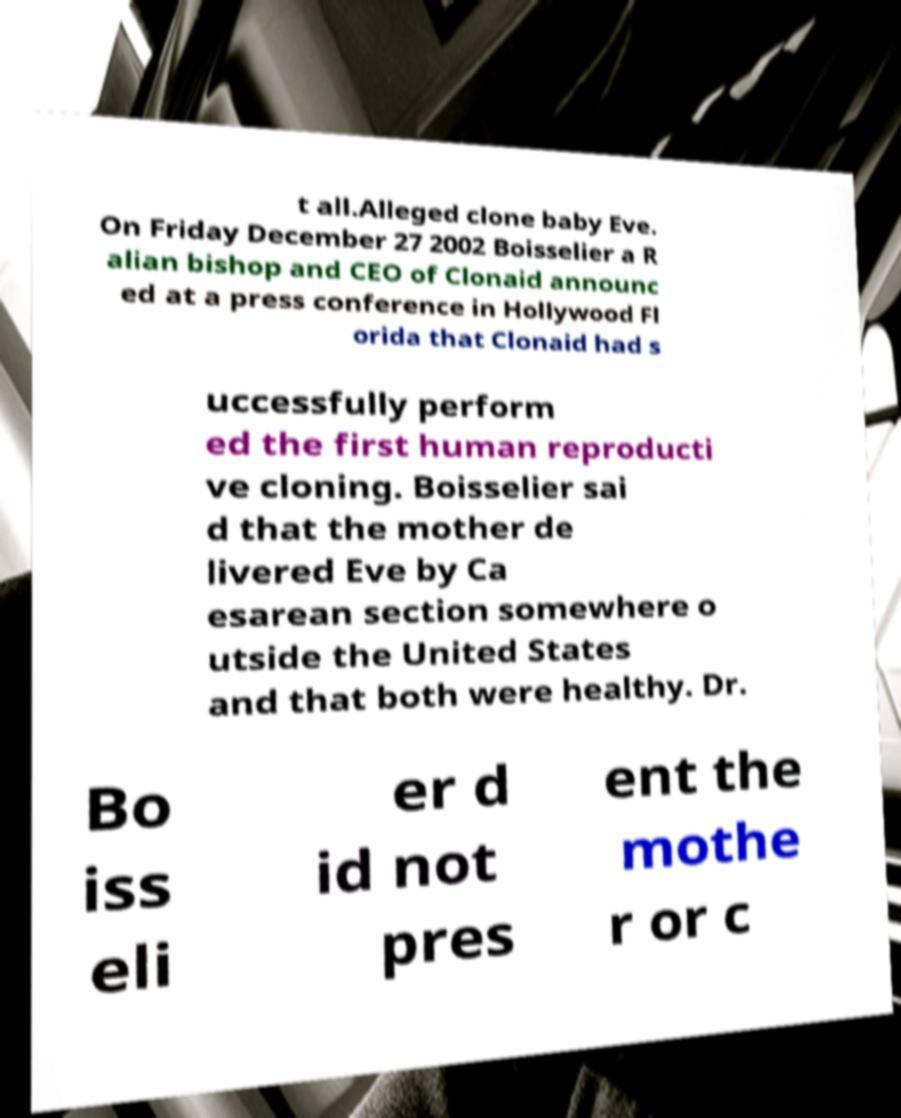Please identify and transcribe the text found in this image. t all.Alleged clone baby Eve. On Friday December 27 2002 Boisselier a R alian bishop and CEO of Clonaid announc ed at a press conference in Hollywood Fl orida that Clonaid had s uccessfully perform ed the first human reproducti ve cloning. Boisselier sai d that the mother de livered Eve by Ca esarean section somewhere o utside the United States and that both were healthy. Dr. Bo iss eli er d id not pres ent the mothe r or c 